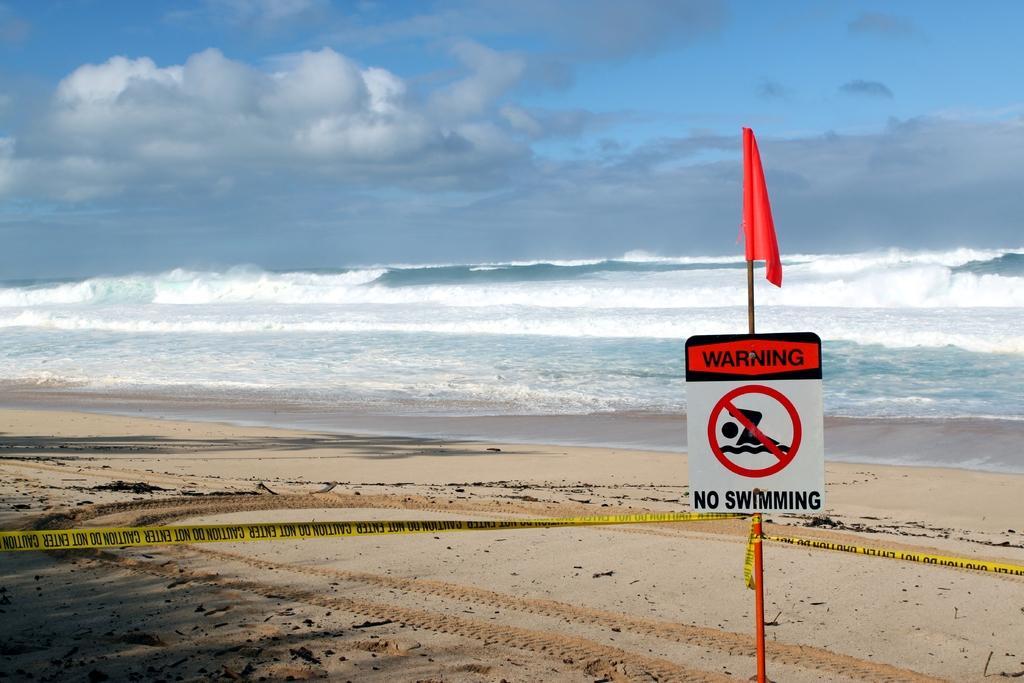Can you describe this image briefly? In the image we can see there is a sign board kept on the ground and the ground is covered with sand. There are caution tape tied around the sign board and there is a flag kept on the sign board. Behind there is an ocean and there is a cloudy sky. 